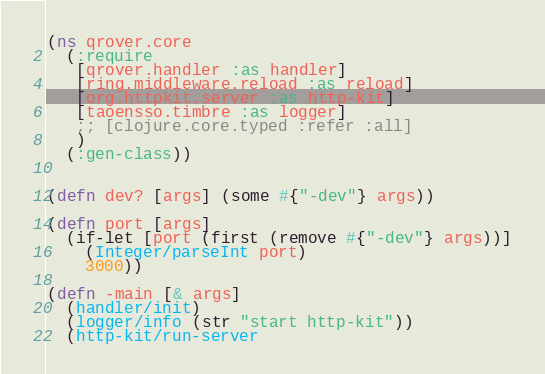<code> <loc_0><loc_0><loc_500><loc_500><_Clojure_>(ns qrover.core
  (:require
   [qrover.handler :as handler]
   [ring.middleware.reload :as reload]
   [org.httpkit.server :as http-kit]
   [taoensso.timbre :as logger]
   ;; [clojure.core.typed :refer :all]
   )
  (:gen-class))


(defn dev? [args] (some #{"-dev"} args))

(defn port [args]
  (if-let [port (first (remove #{"-dev"} args))]
    (Integer/parseInt port)
    3000))

(defn -main [& args]
  (handler/init)
  (logger/info (str "start http-kit"))
  (http-kit/run-server</code> 